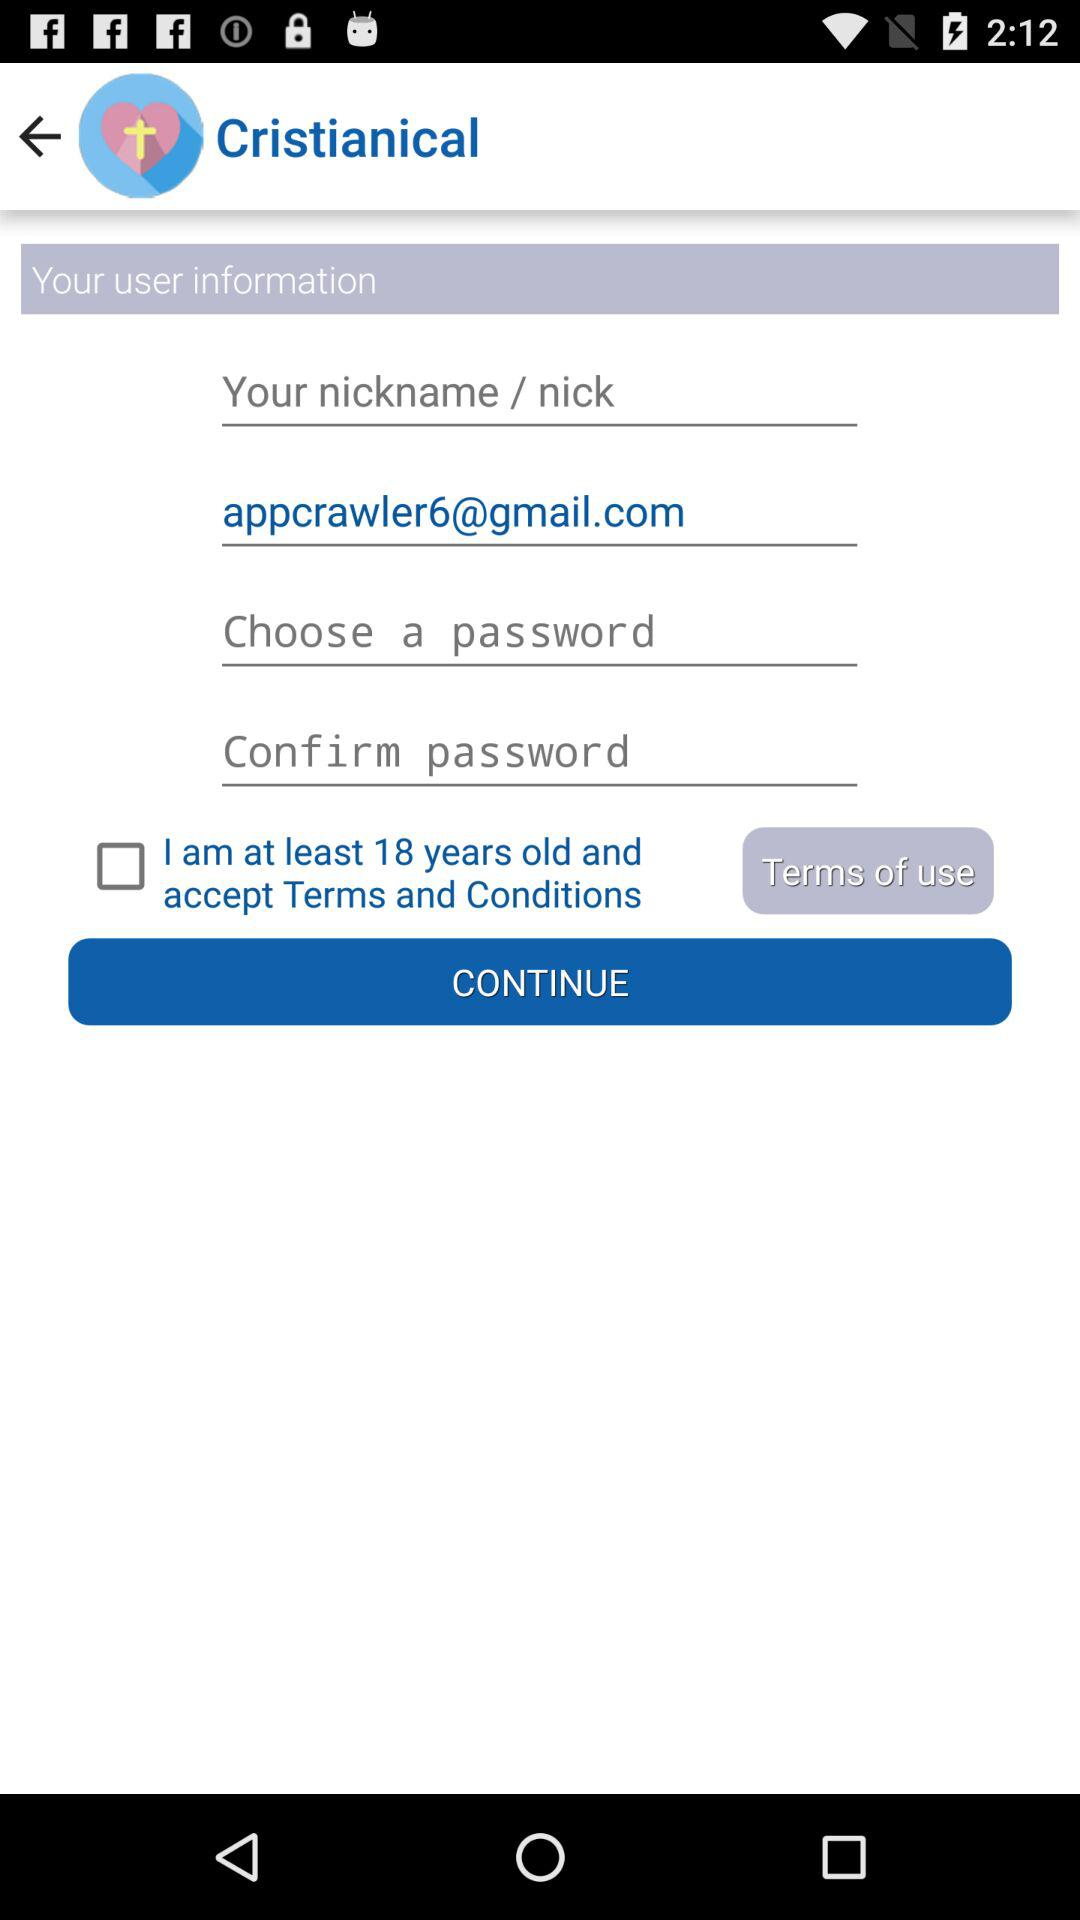What is the age limit for the profile? The age limit is 18 years old. 